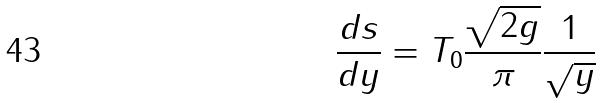Convert formula to latex. <formula><loc_0><loc_0><loc_500><loc_500>\frac { d s } { d y } = T _ { 0 } \frac { \sqrt { 2 g } } { \pi } \frac { 1 } { \sqrt { y } }</formula> 